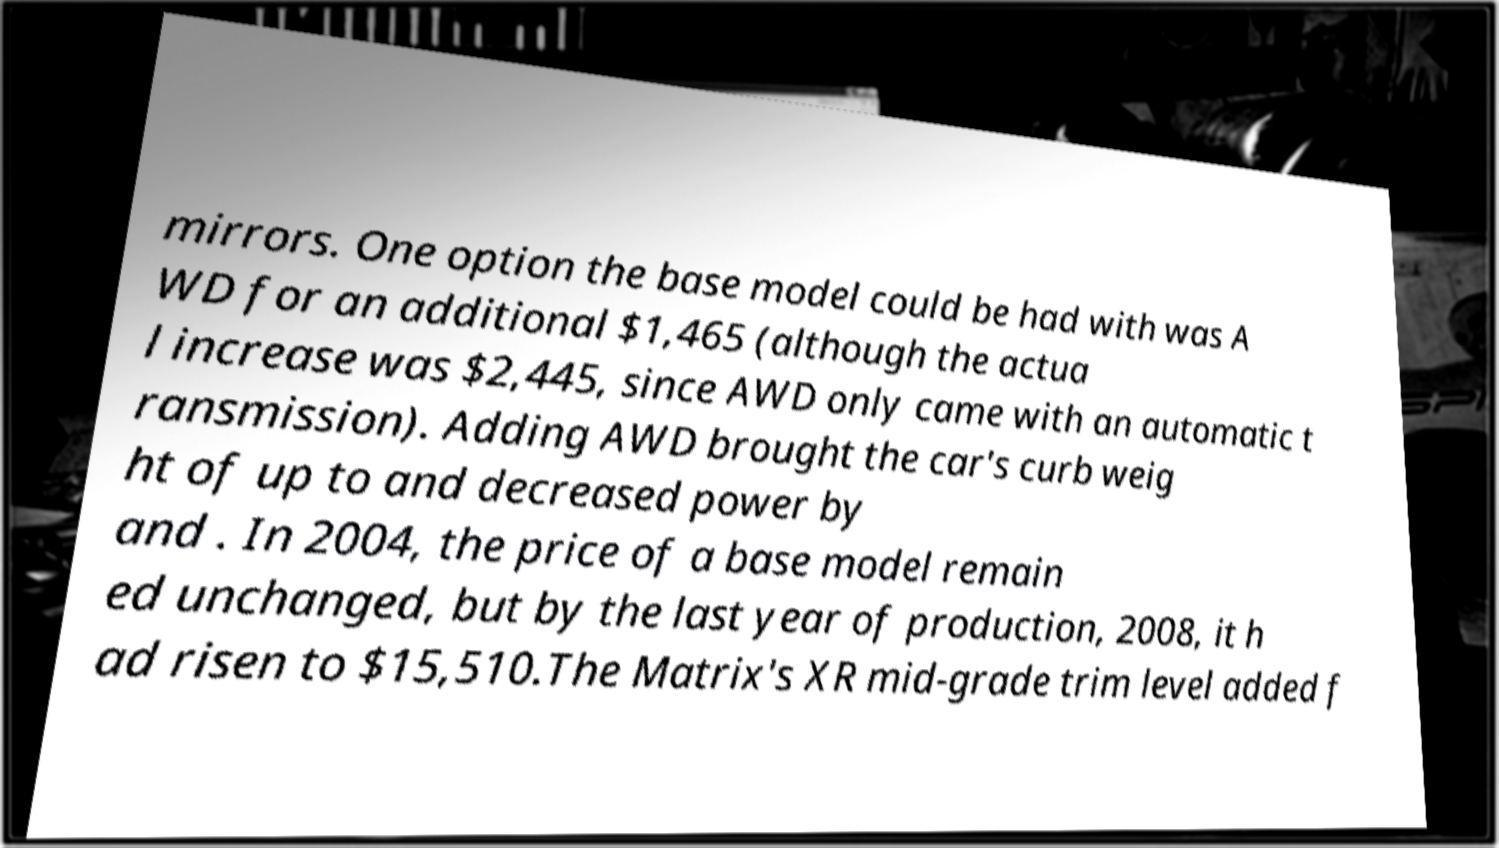Could you assist in decoding the text presented in this image and type it out clearly? mirrors. One option the base model could be had with was A WD for an additional $1,465 (although the actua l increase was $2,445, since AWD only came with an automatic t ransmission). Adding AWD brought the car's curb weig ht of up to and decreased power by and . In 2004, the price of a base model remain ed unchanged, but by the last year of production, 2008, it h ad risen to $15,510.The Matrix's XR mid-grade trim level added f 